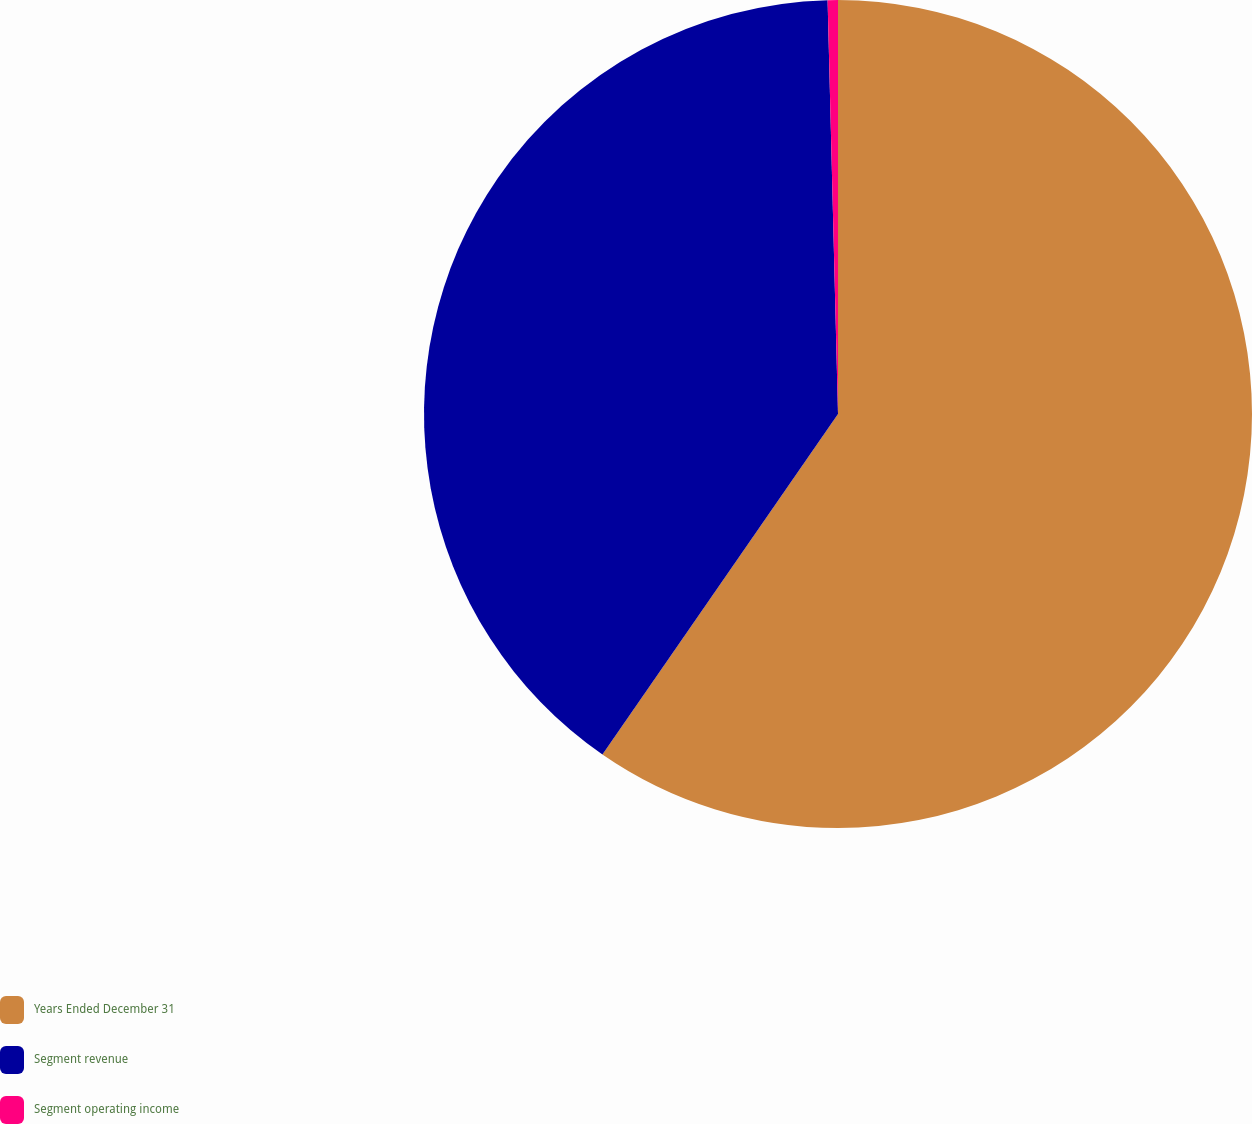Convert chart. <chart><loc_0><loc_0><loc_500><loc_500><pie_chart><fcel>Years Ended December 31<fcel>Segment revenue<fcel>Segment operating income<nl><fcel>59.64%<fcel>39.97%<fcel>0.4%<nl></chart> 